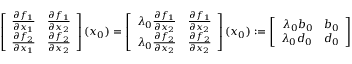Convert formula to latex. <formula><loc_0><loc_0><loc_500><loc_500>\left [ \begin{array} { r } { \frac { \partial f _ { 1 } } { \partial x _ { 1 } } \quad f r a c { \partial f _ { 1 } } { \partial x _ { 2 } } } \\ { \frac { \partial f _ { 2 } } { \partial x _ { 1 } } \quad f r a c { \partial f _ { 2 } } { \partial x _ { 2 } } } \end{array} \right ] ( { x _ { 0 } } ) = \left [ \begin{array} { r } { \lambda _ { 0 } \frac { \partial f _ { 1 } } { \partial x _ { 2 } } \quad f r a c { \partial f _ { 1 } } { \partial x _ { 2 } } } \\ { \lambda _ { 0 } \frac { \partial f _ { 2 } } { \partial x _ { 2 } } \quad f r a c { \partial f _ { 2 } } { \partial x _ { 2 } } } \end{array} \right ] ( { x _ { 0 } } ) \colon = \left [ \begin{array} { r } { \lambda _ { 0 } b _ { 0 } \quad b _ { 0 } } \\ { \lambda _ { 0 } d _ { 0 } \quad d _ { 0 } } \end{array} \right ]</formula> 